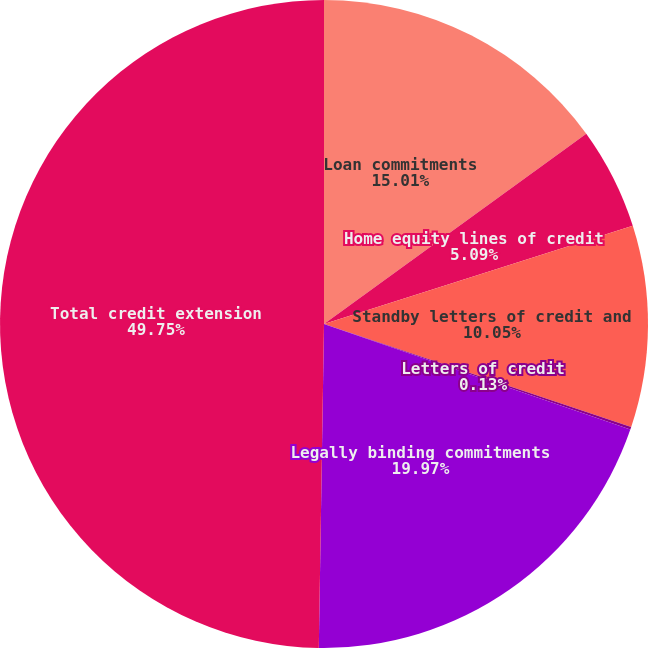<chart> <loc_0><loc_0><loc_500><loc_500><pie_chart><fcel>Loan commitments<fcel>Home equity lines of credit<fcel>Standby letters of credit and<fcel>Letters of credit<fcel>Legally binding commitments<fcel>Total credit extension<nl><fcel>15.01%<fcel>5.09%<fcel>10.05%<fcel>0.13%<fcel>19.97%<fcel>49.74%<nl></chart> 